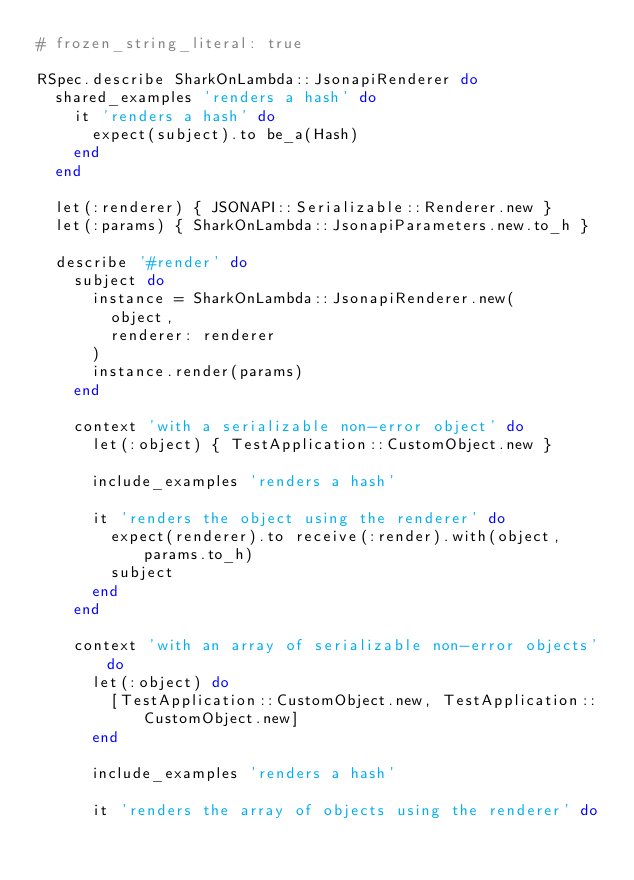Convert code to text. <code><loc_0><loc_0><loc_500><loc_500><_Ruby_># frozen_string_literal: true

RSpec.describe SharkOnLambda::JsonapiRenderer do
  shared_examples 'renders a hash' do
    it 'renders a hash' do
      expect(subject).to be_a(Hash)
    end
  end

  let(:renderer) { JSONAPI::Serializable::Renderer.new }
  let(:params) { SharkOnLambda::JsonapiParameters.new.to_h }

  describe '#render' do
    subject do
      instance = SharkOnLambda::JsonapiRenderer.new(
        object,
        renderer: renderer
      )
      instance.render(params)
    end

    context 'with a serializable non-error object' do
      let(:object) { TestApplication::CustomObject.new }

      include_examples 'renders a hash'

      it 'renders the object using the renderer' do
        expect(renderer).to receive(:render).with(object, params.to_h)
        subject
      end
    end

    context 'with an array of serializable non-error objects' do
      let(:object) do
        [TestApplication::CustomObject.new, TestApplication::CustomObject.new]
      end

      include_examples 'renders a hash'

      it 'renders the array of objects using the renderer' do</code> 